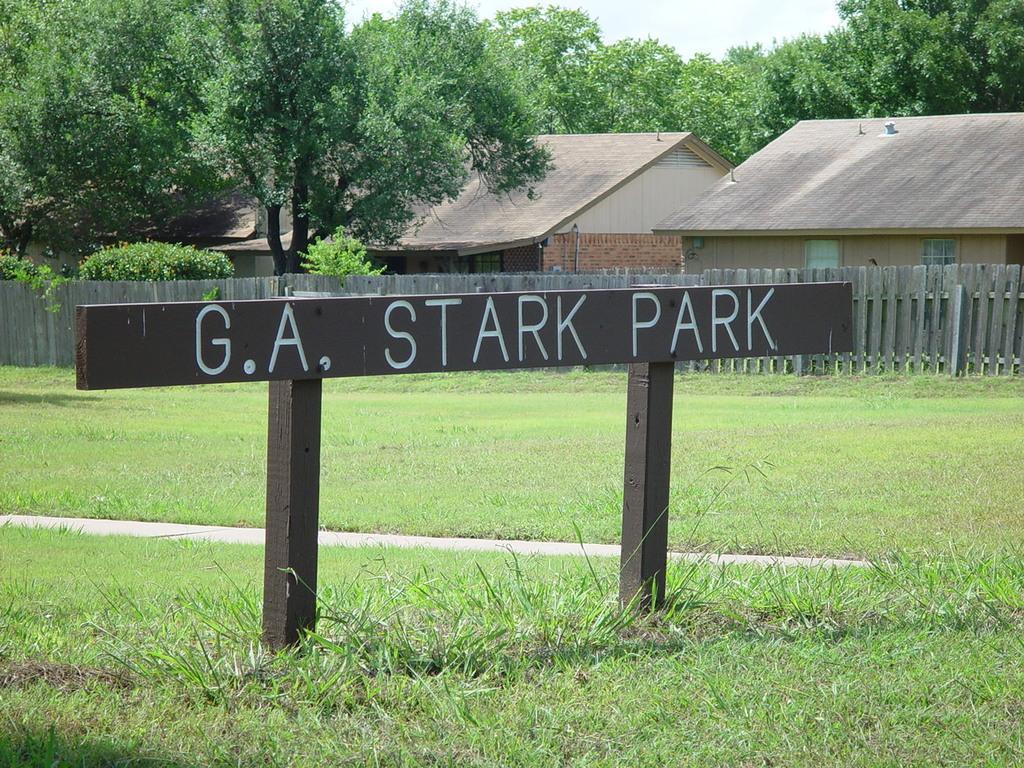Can you describe this image briefly? In this picture we can see a board in the front, at the bottom there is some grass, in the background we can see trees and houses, there is the sky at the top of the picture. 